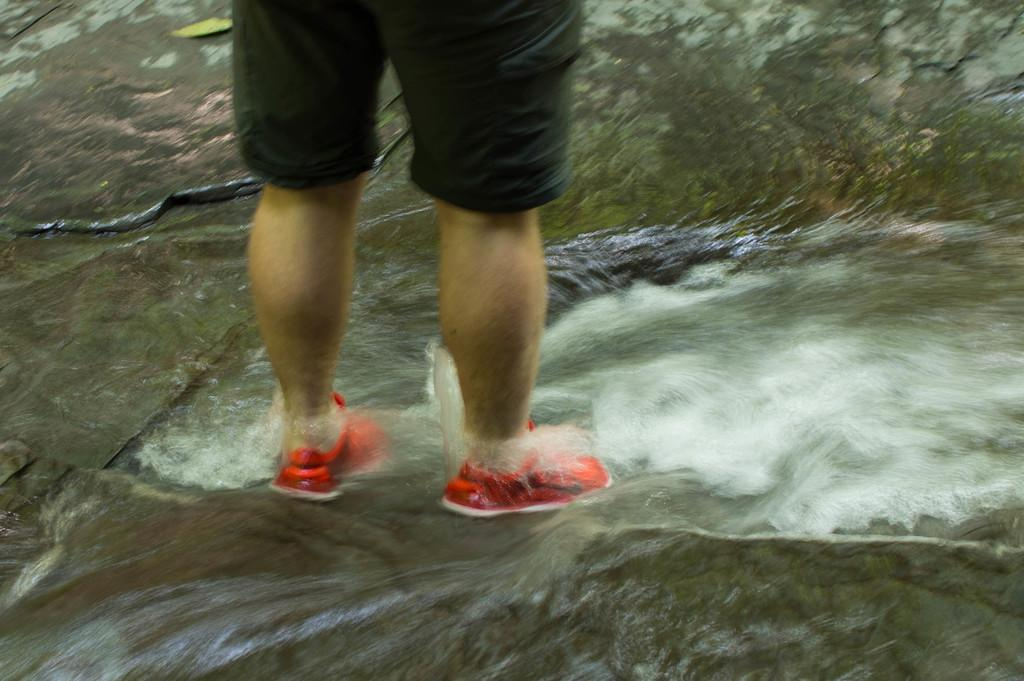What is happening on the rock in the image? There is water flowing on a rock in the image. Is there anyone in the image interacting with the water? Yes, there is there is, a person is standing on the water. What is the person wearing on their feet? The person is wearing shoes. What type of hose is being used to control the temper of the stranger in the image? There is no hose or stranger present in the image. 